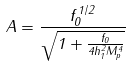<formula> <loc_0><loc_0><loc_500><loc_500>A = \frac { f _ { 0 } ^ { 1 / 2 } } { \sqrt { 1 + \frac { f _ { 0 } } { 4 h _ { 1 } ^ { 2 } M _ { p } ^ { 4 } } } }</formula> 